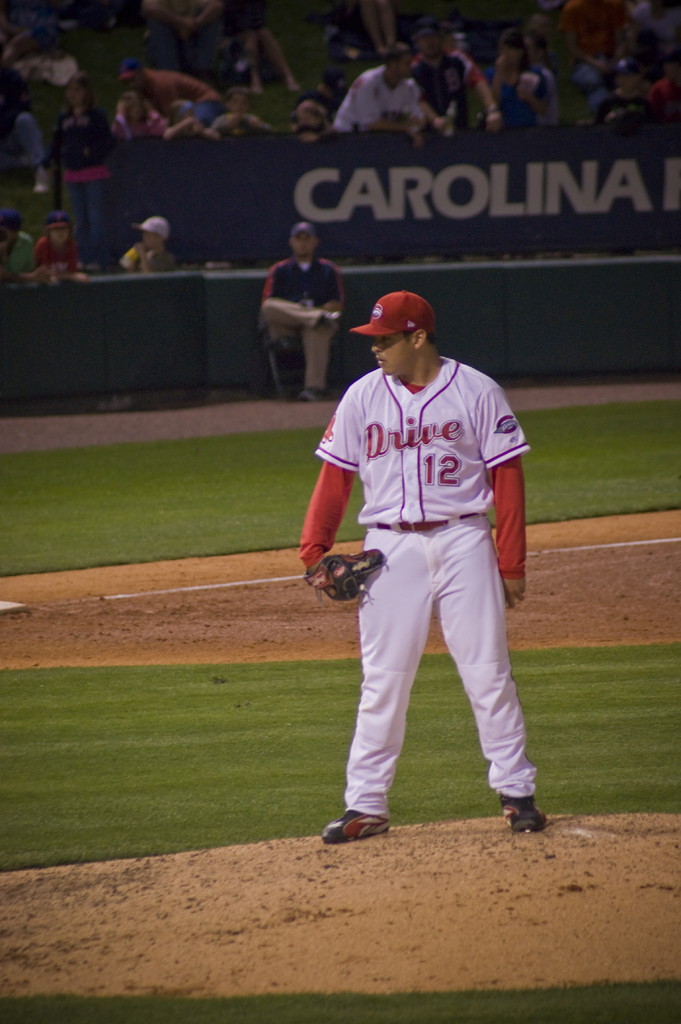What does the lighting tell us about the time of day this game might be taking place? The artificial lighting and the overall ambiance suggest that the game is occurring at night, which is a common practice for professional baseball games to accommodate large audiences. 